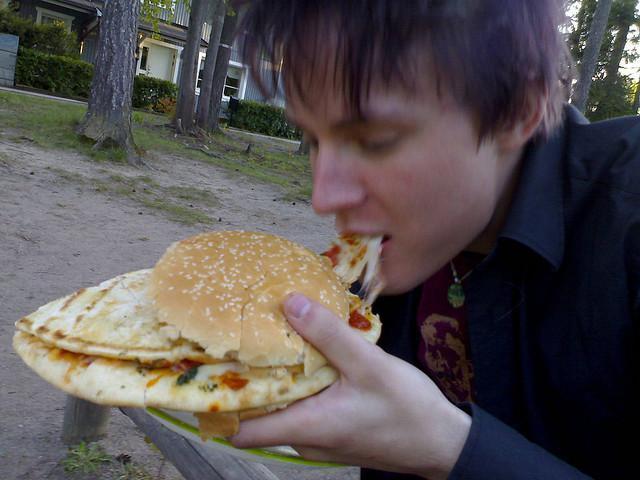Does the image validate the caption "The sandwich is touching the person."?
Answer yes or no. Yes. 